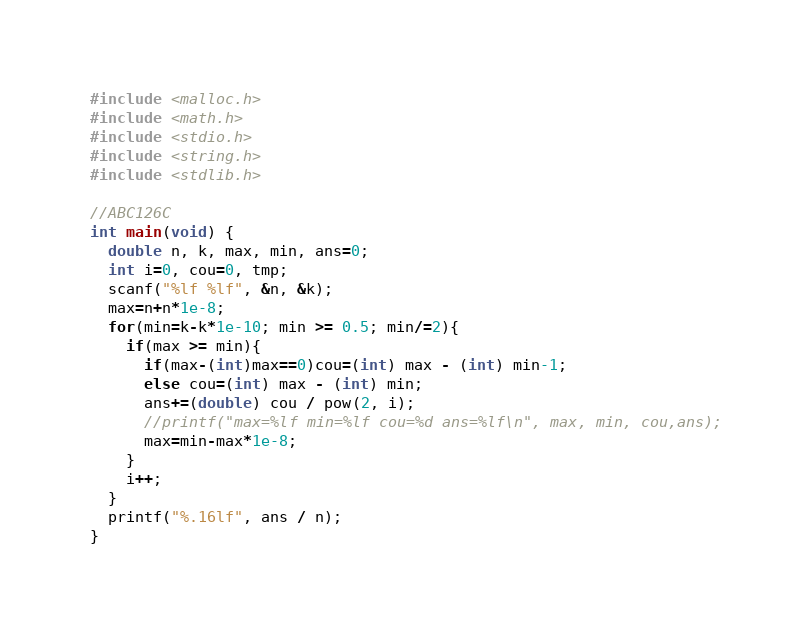Convert code to text. <code><loc_0><loc_0><loc_500><loc_500><_C_>#include <malloc.h>
#include <math.h>
#include <stdio.h>
#include <string.h>
#include <stdlib.h>

//ABC126C
int main(void) {
  double n, k, max, min, ans=0;
  int i=0, cou=0, tmp;
  scanf("%lf %lf", &n, &k);
  max=n+n*1e-8;
  for(min=k-k*1e-10; min >= 0.5; min/=2){
    if(max >= min){
      if(max-(int)max==0)cou=(int) max - (int) min-1;
      else cou=(int) max - (int) min;
      ans+=(double) cou / pow(2, i);
      //printf("max=%lf min=%lf cou=%d ans=%lf\n", max, min, cou,ans);
      max=min-max*1e-8;
    }
    i++;
  }
  printf("%.16lf", ans / n);
}</code> 